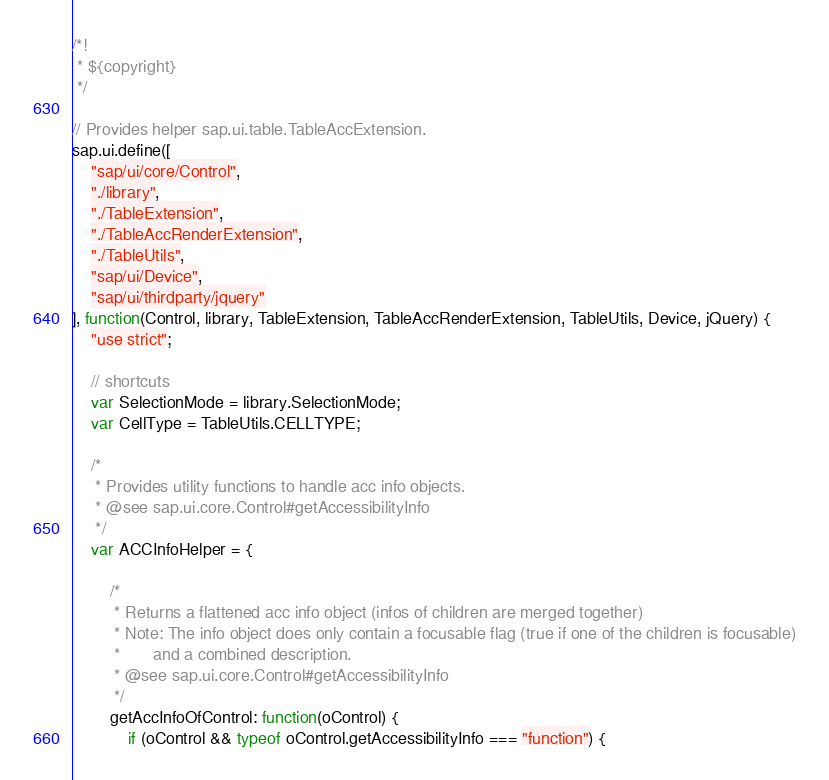<code> <loc_0><loc_0><loc_500><loc_500><_JavaScript_>/*!
 * ${copyright}
 */

// Provides helper sap.ui.table.TableAccExtension.
sap.ui.define([
	"sap/ui/core/Control",
	"./library",
	"./TableExtension",
	"./TableAccRenderExtension",
	"./TableUtils",
	"sap/ui/Device",
	"sap/ui/thirdparty/jquery"
], function(Control, library, TableExtension, TableAccRenderExtension, TableUtils, Device, jQuery) {
	"use strict";

	// shortcuts
	var SelectionMode = library.SelectionMode;
	var CellType = TableUtils.CELLTYPE;

	/*
	 * Provides utility functions to handle acc info objects.
	 * @see sap.ui.core.Control#getAccessibilityInfo
	 */
	var ACCInfoHelper = {

		/*
		 * Returns a flattened acc info object (infos of children are merged together)
		 * Note: The info object does only contain a focusable flag (true if one of the children is focusable)
		 *       and a combined description.
		 * @see sap.ui.core.Control#getAccessibilityInfo
		 */
		getAccInfoOfControl: function(oControl) {
			if (oControl && typeof oControl.getAccessibilityInfo === "function") {</code> 